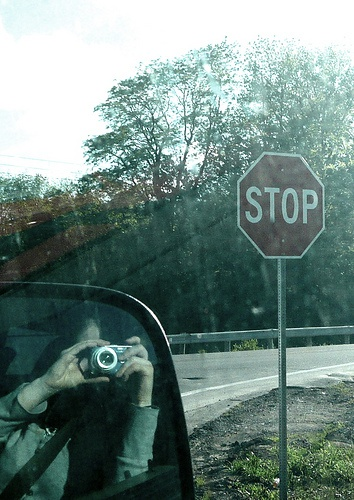Describe the objects in this image and their specific colors. I can see people in white, black, and teal tones and stop sign in white, gray, lightblue, and black tones in this image. 